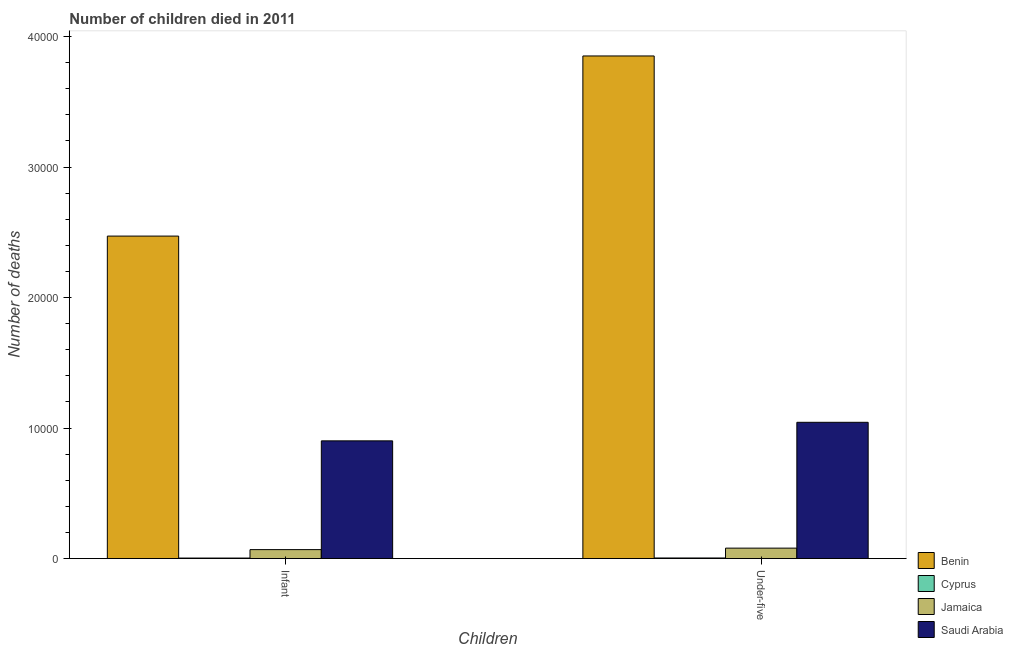How many groups of bars are there?
Keep it short and to the point. 2. Are the number of bars per tick equal to the number of legend labels?
Make the answer very short. Yes. Are the number of bars on each tick of the X-axis equal?
Offer a very short reply. Yes. How many bars are there on the 1st tick from the right?
Your answer should be compact. 4. What is the label of the 1st group of bars from the left?
Your answer should be compact. Infant. What is the number of infant deaths in Jamaica?
Give a very brief answer. 686. Across all countries, what is the maximum number of under-five deaths?
Provide a short and direct response. 3.85e+04. Across all countries, what is the minimum number of under-five deaths?
Give a very brief answer. 45. In which country was the number of infant deaths maximum?
Provide a succinct answer. Benin. In which country was the number of infant deaths minimum?
Offer a very short reply. Cyprus. What is the total number of under-five deaths in the graph?
Offer a very short reply. 4.98e+04. What is the difference between the number of infant deaths in Jamaica and that in Benin?
Ensure brevity in your answer.  -2.40e+04. What is the difference between the number of infant deaths in Benin and the number of under-five deaths in Saudi Arabia?
Offer a terse response. 1.43e+04. What is the average number of under-five deaths per country?
Keep it short and to the point. 1.24e+04. What is the difference between the number of under-five deaths and number of infant deaths in Benin?
Your answer should be compact. 1.38e+04. In how many countries, is the number of infant deaths greater than 38000 ?
Your answer should be very brief. 0. What is the ratio of the number of under-five deaths in Benin to that in Cyprus?
Keep it short and to the point. 855.78. Is the number of under-five deaths in Saudi Arabia less than that in Cyprus?
Your answer should be very brief. No. What does the 1st bar from the left in Infant represents?
Offer a very short reply. Benin. What does the 2nd bar from the right in Under-five represents?
Your response must be concise. Jamaica. How many bars are there?
Your response must be concise. 8. Are all the bars in the graph horizontal?
Give a very brief answer. No. What is the difference between two consecutive major ticks on the Y-axis?
Provide a succinct answer. 10000. Are the values on the major ticks of Y-axis written in scientific E-notation?
Provide a short and direct response. No. How many legend labels are there?
Offer a terse response. 4. How are the legend labels stacked?
Ensure brevity in your answer.  Vertical. What is the title of the graph?
Your answer should be compact. Number of children died in 2011. What is the label or title of the X-axis?
Give a very brief answer. Children. What is the label or title of the Y-axis?
Provide a short and direct response. Number of deaths. What is the Number of deaths in Benin in Infant?
Give a very brief answer. 2.47e+04. What is the Number of deaths in Cyprus in Infant?
Your response must be concise. 39. What is the Number of deaths of Jamaica in Infant?
Offer a very short reply. 686. What is the Number of deaths of Saudi Arabia in Infant?
Provide a succinct answer. 9019. What is the Number of deaths in Benin in Under-five?
Make the answer very short. 3.85e+04. What is the Number of deaths of Jamaica in Under-five?
Keep it short and to the point. 799. What is the Number of deaths in Saudi Arabia in Under-five?
Make the answer very short. 1.04e+04. Across all Children, what is the maximum Number of deaths in Benin?
Provide a short and direct response. 3.85e+04. Across all Children, what is the maximum Number of deaths in Jamaica?
Give a very brief answer. 799. Across all Children, what is the maximum Number of deaths in Saudi Arabia?
Your answer should be compact. 1.04e+04. Across all Children, what is the minimum Number of deaths of Benin?
Make the answer very short. 2.47e+04. Across all Children, what is the minimum Number of deaths of Cyprus?
Make the answer very short. 39. Across all Children, what is the minimum Number of deaths of Jamaica?
Your answer should be very brief. 686. Across all Children, what is the minimum Number of deaths in Saudi Arabia?
Make the answer very short. 9019. What is the total Number of deaths of Benin in the graph?
Your response must be concise. 6.32e+04. What is the total Number of deaths of Jamaica in the graph?
Give a very brief answer. 1485. What is the total Number of deaths in Saudi Arabia in the graph?
Your answer should be very brief. 1.95e+04. What is the difference between the Number of deaths in Benin in Infant and that in Under-five?
Offer a very short reply. -1.38e+04. What is the difference between the Number of deaths in Cyprus in Infant and that in Under-five?
Your answer should be compact. -6. What is the difference between the Number of deaths of Jamaica in Infant and that in Under-five?
Offer a very short reply. -113. What is the difference between the Number of deaths in Saudi Arabia in Infant and that in Under-five?
Make the answer very short. -1421. What is the difference between the Number of deaths in Benin in Infant and the Number of deaths in Cyprus in Under-five?
Ensure brevity in your answer.  2.47e+04. What is the difference between the Number of deaths of Benin in Infant and the Number of deaths of Jamaica in Under-five?
Provide a short and direct response. 2.39e+04. What is the difference between the Number of deaths in Benin in Infant and the Number of deaths in Saudi Arabia in Under-five?
Offer a terse response. 1.43e+04. What is the difference between the Number of deaths of Cyprus in Infant and the Number of deaths of Jamaica in Under-five?
Offer a very short reply. -760. What is the difference between the Number of deaths in Cyprus in Infant and the Number of deaths in Saudi Arabia in Under-five?
Keep it short and to the point. -1.04e+04. What is the difference between the Number of deaths of Jamaica in Infant and the Number of deaths of Saudi Arabia in Under-five?
Give a very brief answer. -9754. What is the average Number of deaths of Benin per Children?
Your answer should be very brief. 3.16e+04. What is the average Number of deaths in Cyprus per Children?
Provide a succinct answer. 42. What is the average Number of deaths in Jamaica per Children?
Your answer should be compact. 742.5. What is the average Number of deaths of Saudi Arabia per Children?
Offer a terse response. 9729.5. What is the difference between the Number of deaths of Benin and Number of deaths of Cyprus in Infant?
Your answer should be compact. 2.47e+04. What is the difference between the Number of deaths of Benin and Number of deaths of Jamaica in Infant?
Offer a terse response. 2.40e+04. What is the difference between the Number of deaths of Benin and Number of deaths of Saudi Arabia in Infant?
Provide a short and direct response. 1.57e+04. What is the difference between the Number of deaths of Cyprus and Number of deaths of Jamaica in Infant?
Ensure brevity in your answer.  -647. What is the difference between the Number of deaths of Cyprus and Number of deaths of Saudi Arabia in Infant?
Your answer should be very brief. -8980. What is the difference between the Number of deaths in Jamaica and Number of deaths in Saudi Arabia in Infant?
Ensure brevity in your answer.  -8333. What is the difference between the Number of deaths in Benin and Number of deaths in Cyprus in Under-five?
Make the answer very short. 3.85e+04. What is the difference between the Number of deaths of Benin and Number of deaths of Jamaica in Under-five?
Offer a terse response. 3.77e+04. What is the difference between the Number of deaths in Benin and Number of deaths in Saudi Arabia in Under-five?
Your response must be concise. 2.81e+04. What is the difference between the Number of deaths of Cyprus and Number of deaths of Jamaica in Under-five?
Offer a very short reply. -754. What is the difference between the Number of deaths of Cyprus and Number of deaths of Saudi Arabia in Under-five?
Provide a short and direct response. -1.04e+04. What is the difference between the Number of deaths of Jamaica and Number of deaths of Saudi Arabia in Under-five?
Provide a succinct answer. -9641. What is the ratio of the Number of deaths of Benin in Infant to that in Under-five?
Provide a short and direct response. 0.64. What is the ratio of the Number of deaths in Cyprus in Infant to that in Under-five?
Offer a very short reply. 0.87. What is the ratio of the Number of deaths of Jamaica in Infant to that in Under-five?
Give a very brief answer. 0.86. What is the ratio of the Number of deaths of Saudi Arabia in Infant to that in Under-five?
Provide a succinct answer. 0.86. What is the difference between the highest and the second highest Number of deaths in Benin?
Offer a very short reply. 1.38e+04. What is the difference between the highest and the second highest Number of deaths of Cyprus?
Give a very brief answer. 6. What is the difference between the highest and the second highest Number of deaths in Jamaica?
Offer a terse response. 113. What is the difference between the highest and the second highest Number of deaths of Saudi Arabia?
Your answer should be very brief. 1421. What is the difference between the highest and the lowest Number of deaths of Benin?
Offer a terse response. 1.38e+04. What is the difference between the highest and the lowest Number of deaths of Cyprus?
Offer a terse response. 6. What is the difference between the highest and the lowest Number of deaths in Jamaica?
Offer a very short reply. 113. What is the difference between the highest and the lowest Number of deaths of Saudi Arabia?
Ensure brevity in your answer.  1421. 